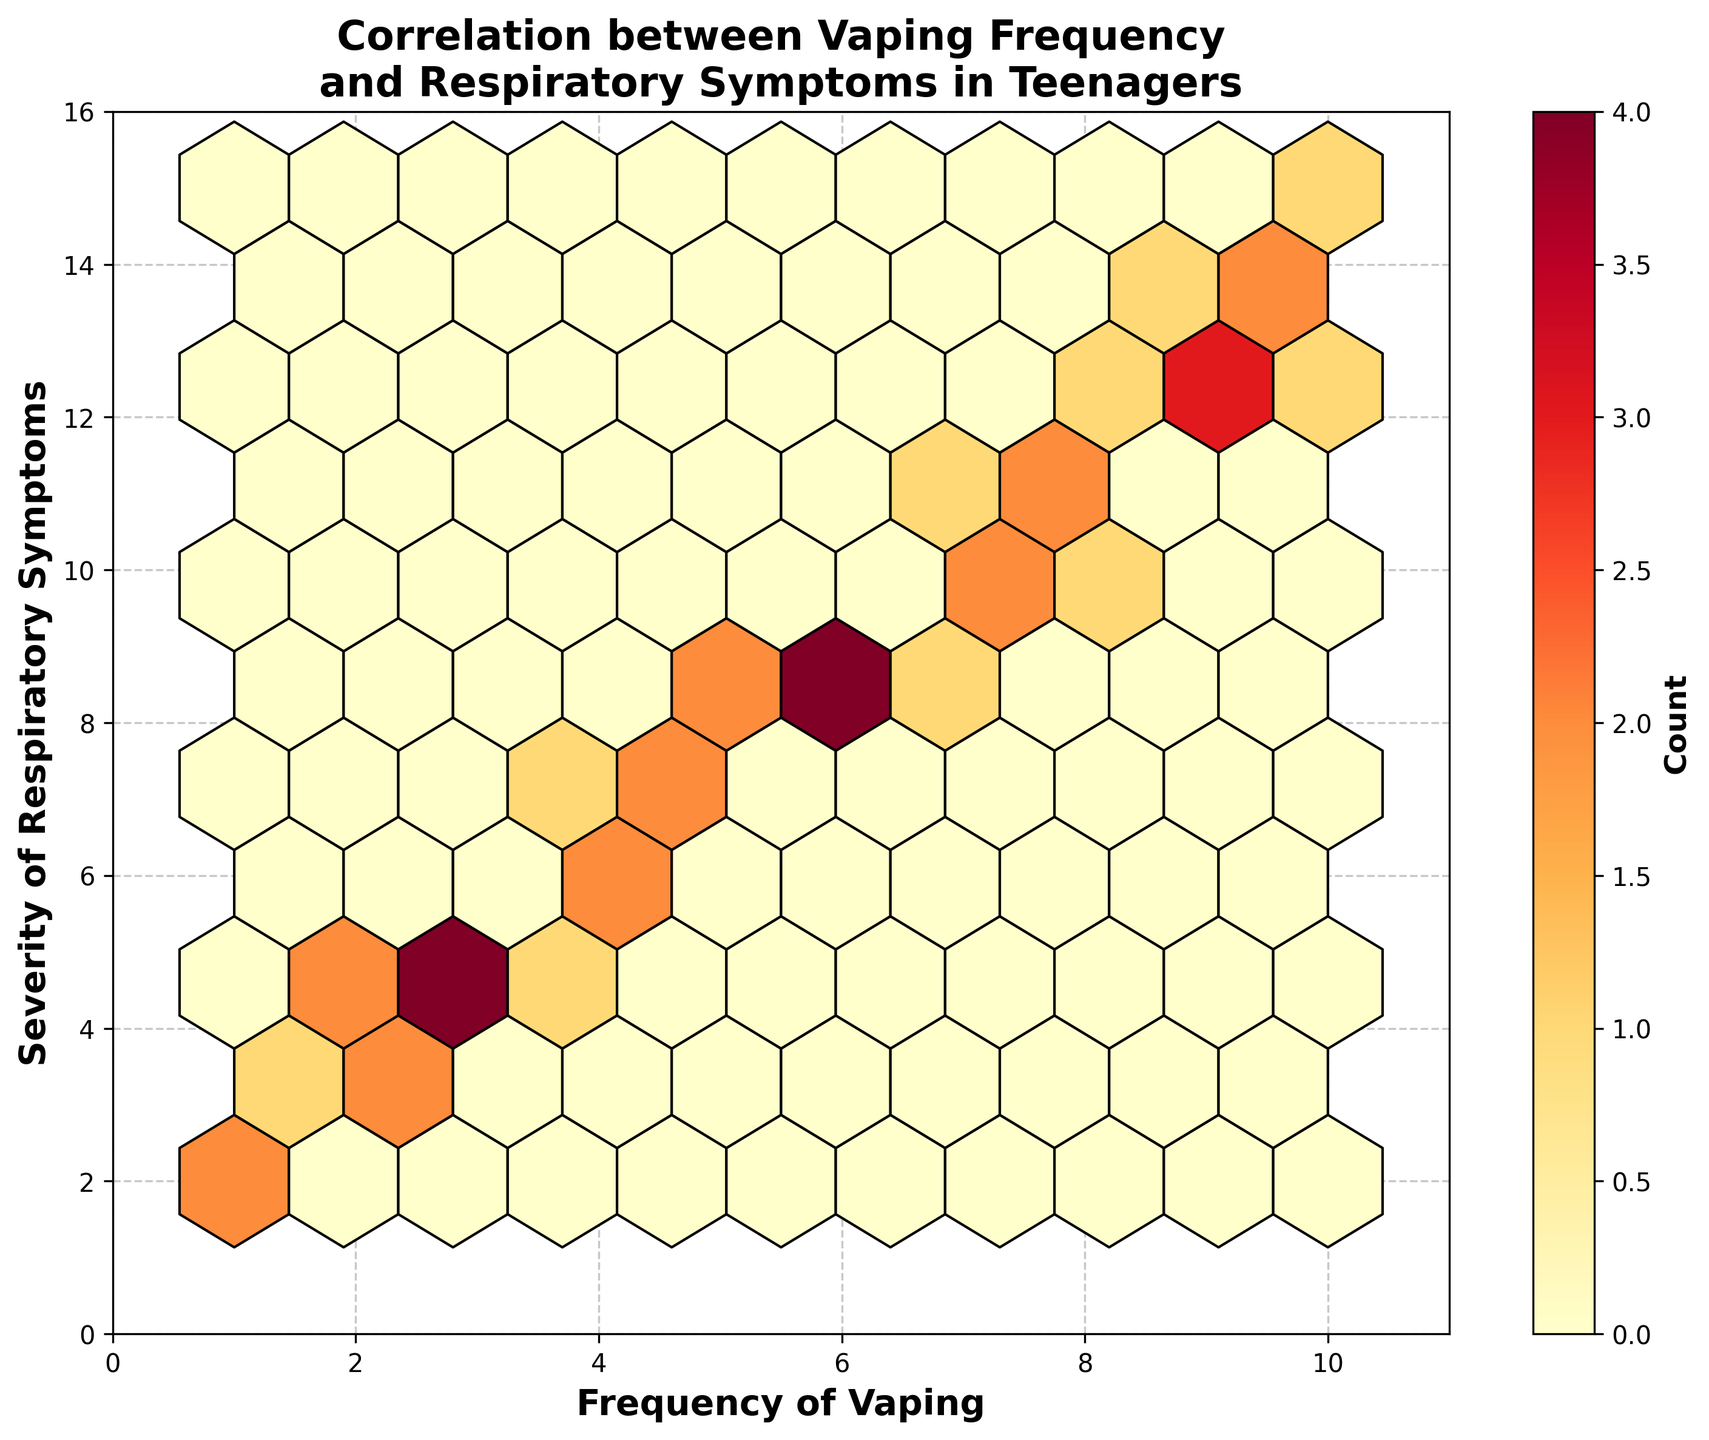What is the title of the Hexbin Plot? The title is usually placed at the top of the plot and gives an overview of what the plot represents. The title of this specific plot is "Correlation between Vaping Frequency and Respiratory Symptoms in Teenagers".
Answer: Correlation between Vaping Frequency and Respiratory Symptoms in Teenagers How many bins are present in the plot? You can count the number of hexagonal bins shown in the plot. There are several hexagonal bins across the plot area. The grid size is set to 10, but this doesn't directly translate to the exact count of hexagonal bins seen. Upon visual inspection, you can roughly see multiple hexagonal bins filling the entire space.
Answer: Multiple bins (exact count not specified) What is the range of the x-axis? The x-axis represents the "Frequency of Vaping". The range can be determined by looking at the minimum and maximum values on the axis. It ranges from 0 to 11.
Answer: 0 to 11 What is the highest value observed on the y-axis? The y-axis represents the "Severity of Respiratory Symptoms". To identify the highest value, check the maximum number displayed on the y-axis. The highest value is 16.
Answer: 16 Which color indicates the highest density of points? The color scale illustrates the density of points within each bin. In the provided plot, "YlOrRd" is the color map used, where darker shades typically represent higher densities. The darkest shade (deep red) indicates the highest density of points.
Answer: Deep red What can you infer about the relationship between the frequency of vaping and severity of symptoms based on the plot? By observing the concentration and distribution of bins, one can infer the correlation between the two variables. There is a visible increasing trend, suggesting that as the frequency of vaping increases, the severity of respiratory symptoms also tends to increase.
Answer: Positive correlation What are the most common values of frequency and severity in the plot? You can determine the most common values by identifying the bins with the highest density (darkest color). These bins represent the values that appear most frequently. Observing the plot, the most common frequency and severity values are around 5-6 for frequency and 8-9 for severity.
Answer: 5-6 for frequency, 8-9 for severity Which areas of the plot have the least density of data points? Identify the areas with the lightest color (near yellow/white), indicating the least data concentration. These areas primarily appear at the lower and upper extremes of the plot.
Answer: Lower frequency and severity, and upper frequency and severity What does the color bar on the right side of the plot represent? The color bar's purpose is to map the colors in the plot to the data point counts within each bin. It provides a legend showing how color intensity corresponds to the number of observations in each hexagonal bin.
Answer: Data point count within bins 